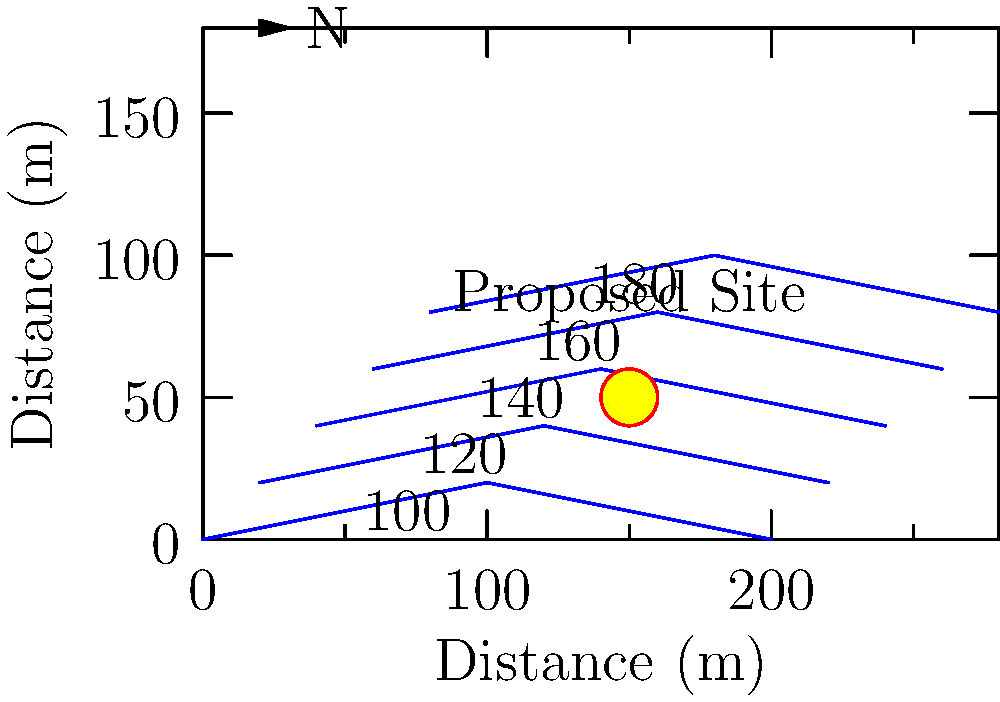As a young voter interested in public works projects, you're reviewing a topographical map for a proposed community center. The map shows contour lines at 20-meter intervals, with the lowest elevation at 100 meters. What is the approximate elevation of the proposed site marked by the red circle? To determine the elevation of the proposed site, we need to follow these steps:

1. Identify the contour lines: Each line represents a specific elevation, increasing by 20 meters per line from bottom to top.

2. Locate the proposed site: The red circle marks the location of the proposed community center.

3. Analyze the site's position relative to contour lines:
   - The site is between the second (120m) and third (140m) contour lines from the bottom.
   - It appears to be slightly closer to the 140m line than the 120m line.

4. Estimate the elevation:
   - Since the site is between 120m and 140m, and slightly closer to 140m, we can estimate it's about 60% of the way between these lines.
   - The difference between lines is 20m, so 60% of 20m is 12m.
   - Add this to the lower contour line: 120m + 12m = 132m.

5. Round to a reasonable precision: Given the nature of topographical estimation, rounding to the nearest 5 meters is appropriate.

Therefore, the approximate elevation of the proposed site is 130 meters.
Answer: 130 meters 